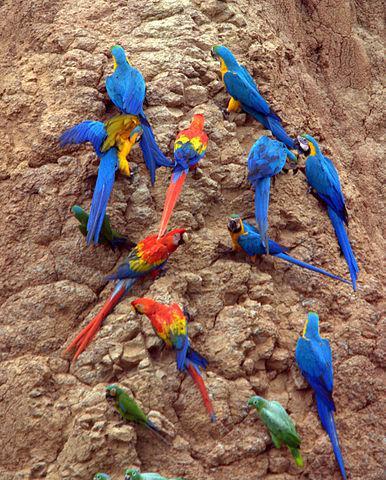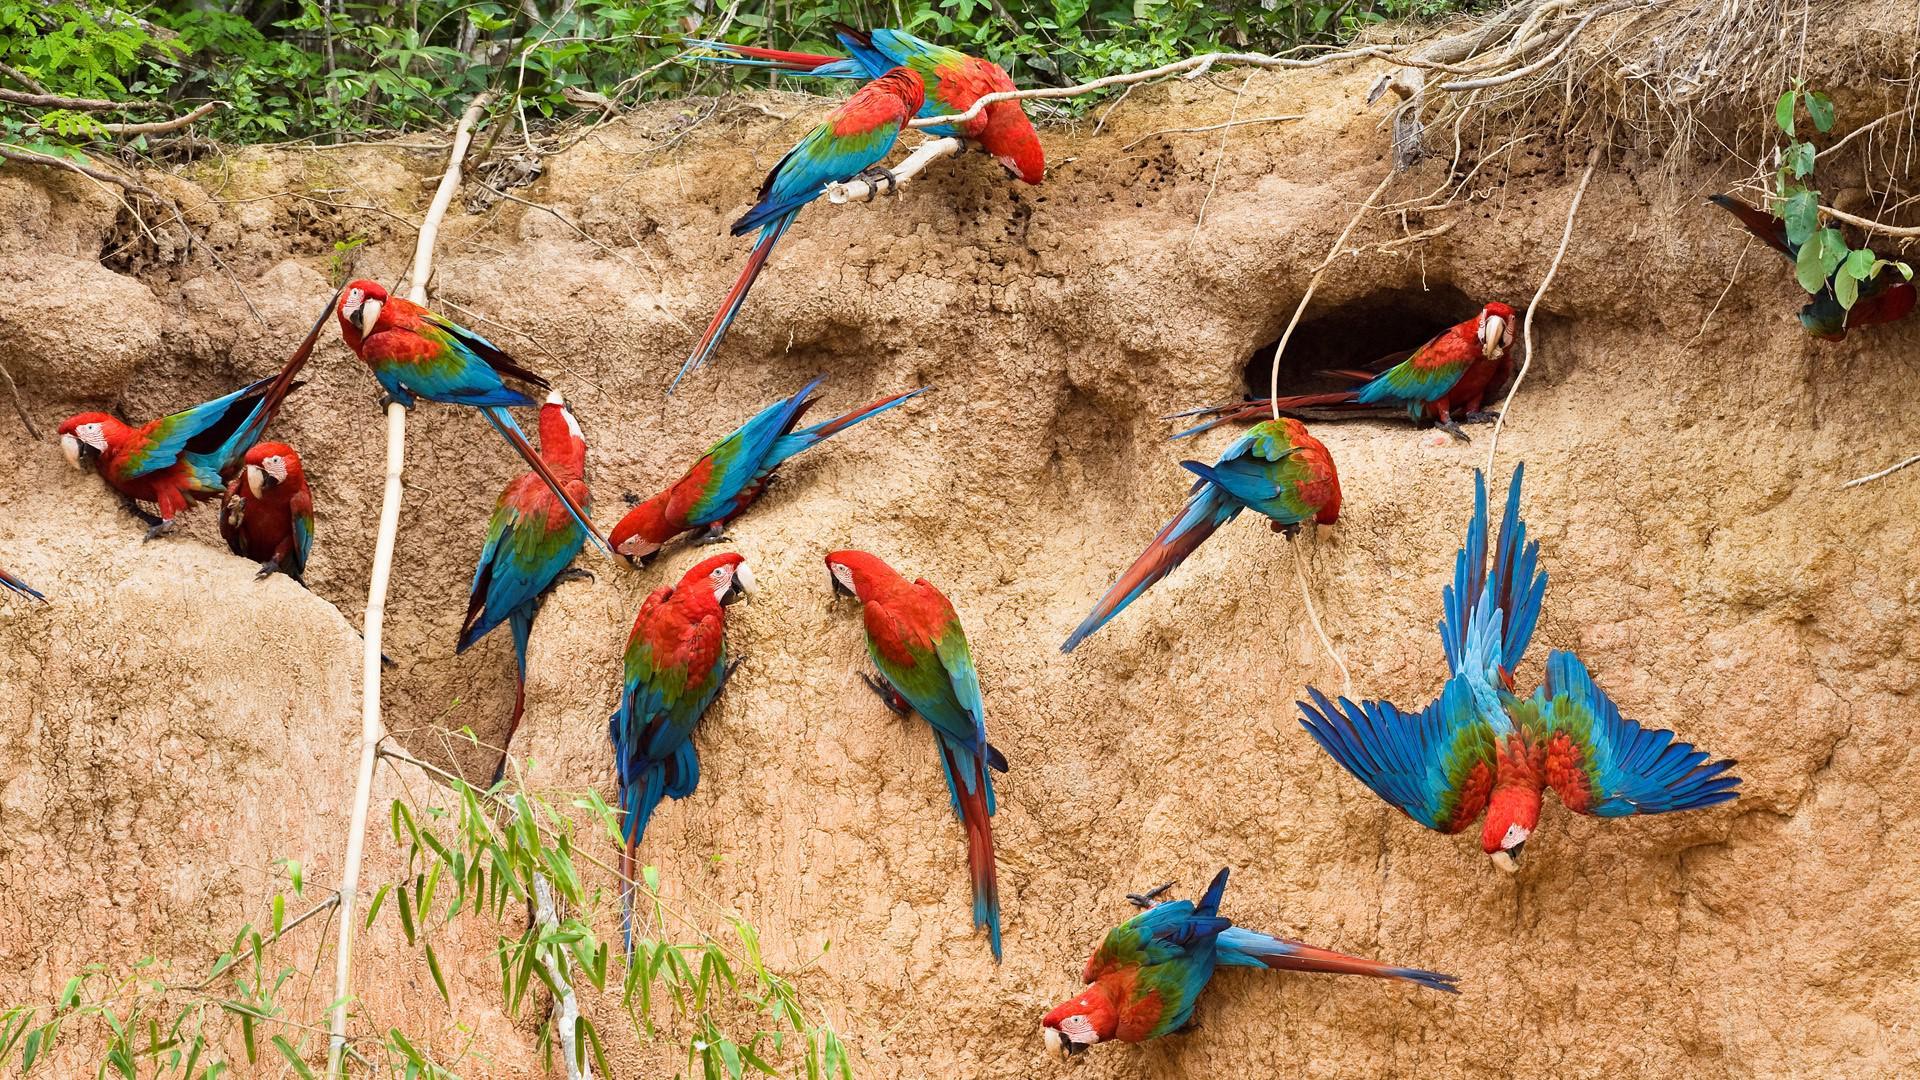The first image is the image on the left, the second image is the image on the right. Evaluate the accuracy of this statement regarding the images: "There are a large number of parrots perched on a rocky wall.". Is it true? Answer yes or no. Yes. The first image is the image on the left, the second image is the image on the right. Analyze the images presented: Is the assertion "The left image contains exactly two parrots." valid? Answer yes or no. No. The first image is the image on the left, the second image is the image on the right. Assess this claim about the two images: "A single blue and yellow bird is perched in one of the images.". Correct or not? Answer yes or no. No. 